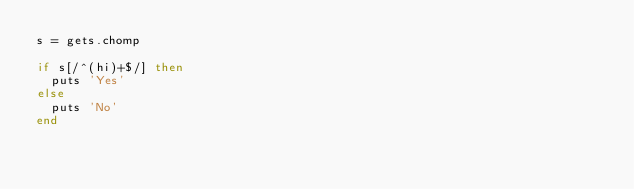Convert code to text. <code><loc_0><loc_0><loc_500><loc_500><_Ruby_>s = gets.chomp

if s[/^(hi)+$/] then
	puts 'Yes'
else
	puts 'No'
end</code> 